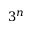<formula> <loc_0><loc_0><loc_500><loc_500>3 ^ { n }</formula> 